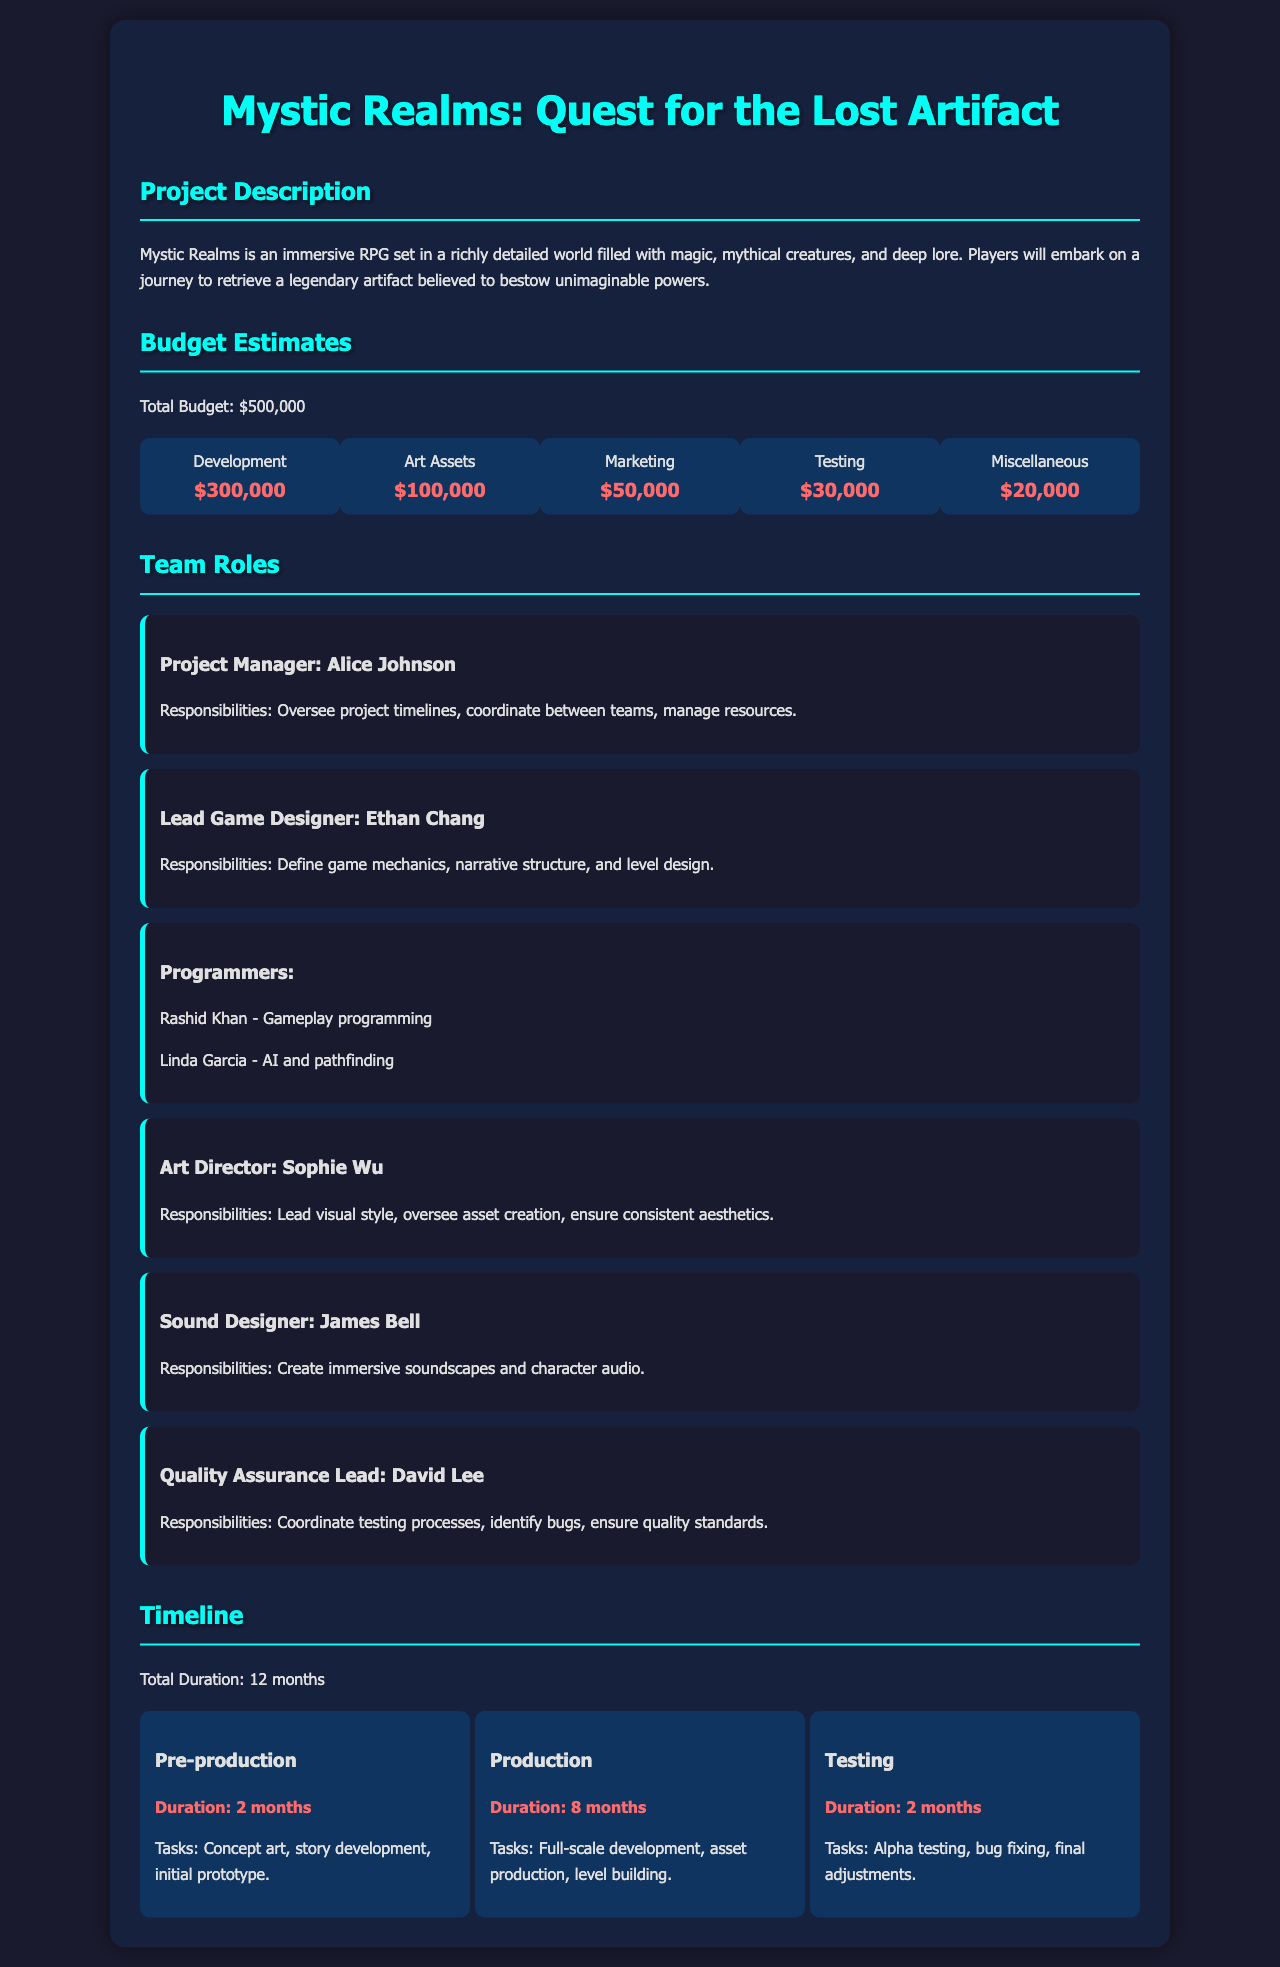What is the project title? The project title is explicitly mentioned in the document as "Mystic Realms: Quest for the Lost Artifact."
Answer: Mystic Realms: Quest for the Lost Artifact What is the total budget? The total budget is specified in the budget estimates section of the document as $500,000.
Answer: $500,000 Who is the Art Director? The document lists Sophie Wu as the Art Director among the team roles.
Answer: Sophie Wu How long is the production phase? The duration of the production phase can be found in the timeline section, stating it lasts for 8 months.
Answer: 8 months What is the role of David Lee? David Lee's responsibilities are described in the team roles section as the Quality Assurance Lead.
Answer: Quality Assurance Lead What percentage of the budget is allocated to Development? The development budget is disclosed as $300,000 out of a total budget of $500,000, which is 60%.
Answer: 60% Which phase includes asset production? The document indicates that the asset production occurs during the production phase.
Answer: Production What is one of the tasks during pre-production? The tasks for pre-production include concept art, as mentioned in the timeline section.
Answer: Concept art How many team members are listed in the document? The document lists six team members across various roles, counting individually.
Answer: Six 